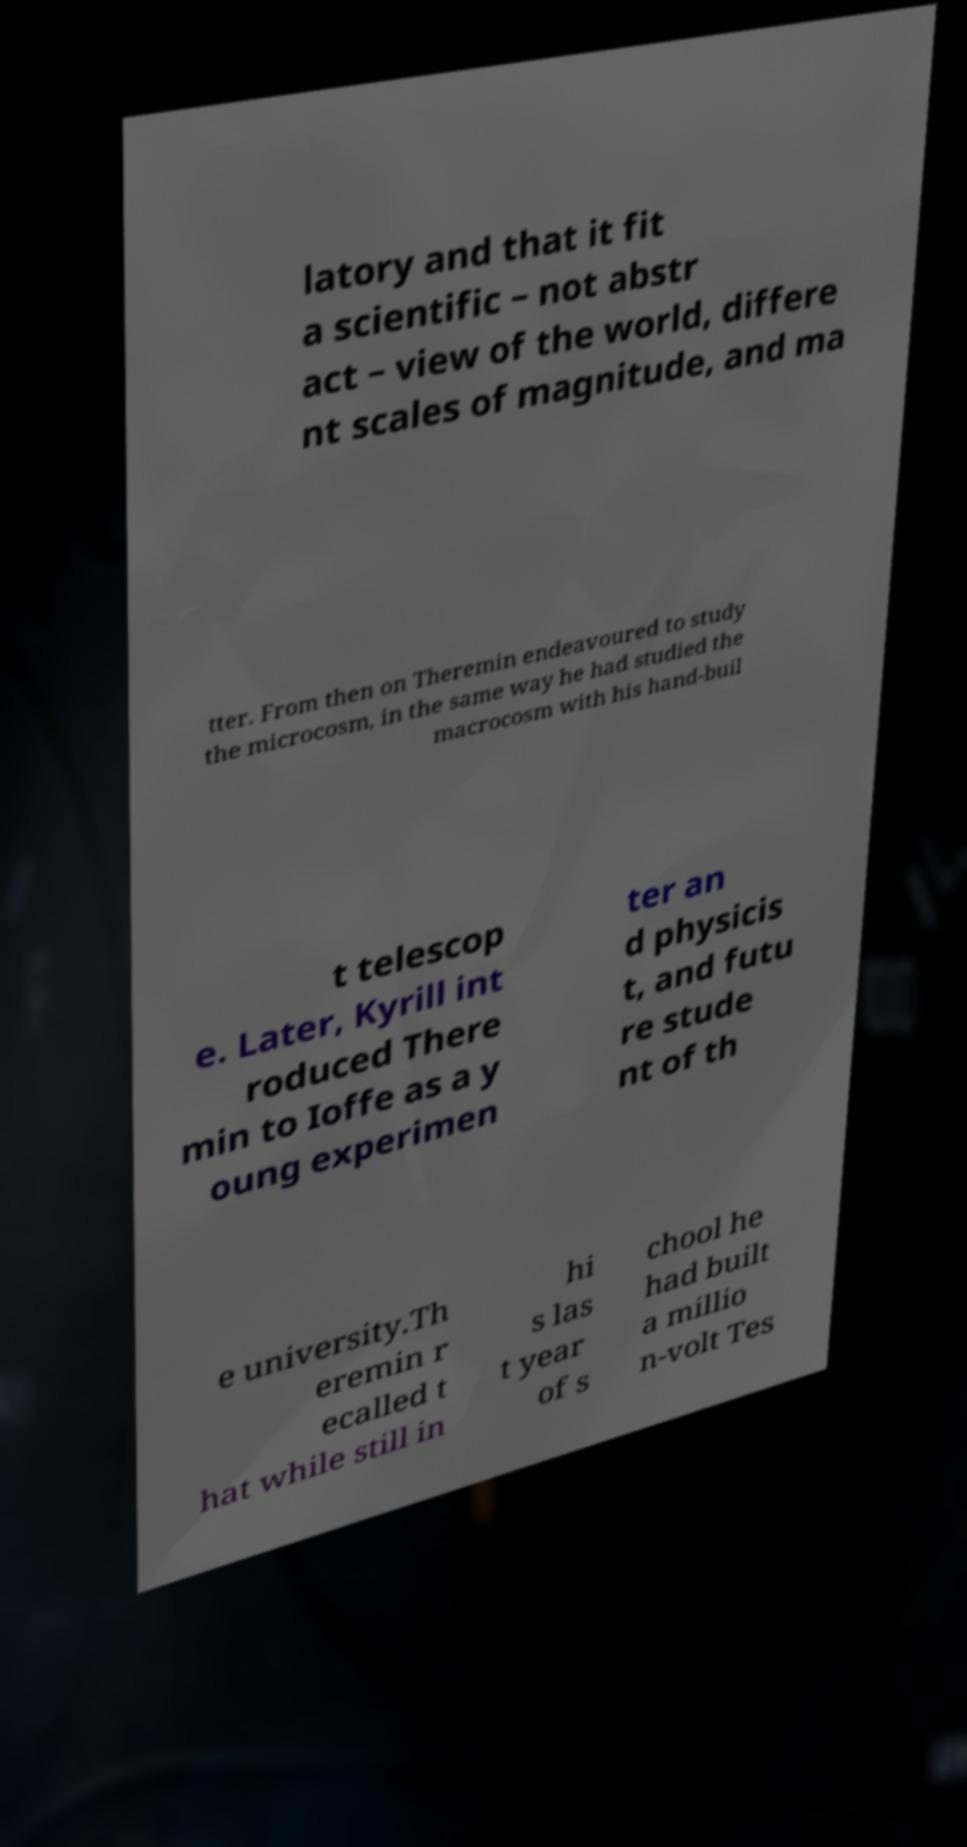Could you extract and type out the text from this image? latory and that it fit a scientific – not abstr act – view of the world, differe nt scales of magnitude, and ma tter. From then on Theremin endeavoured to study the microcosm, in the same way he had studied the macrocosm with his hand-buil t telescop e. Later, Kyrill int roduced There min to Ioffe as a y oung experimen ter an d physicis t, and futu re stude nt of th e university.Th eremin r ecalled t hat while still in hi s las t year of s chool he had built a millio n-volt Tes 